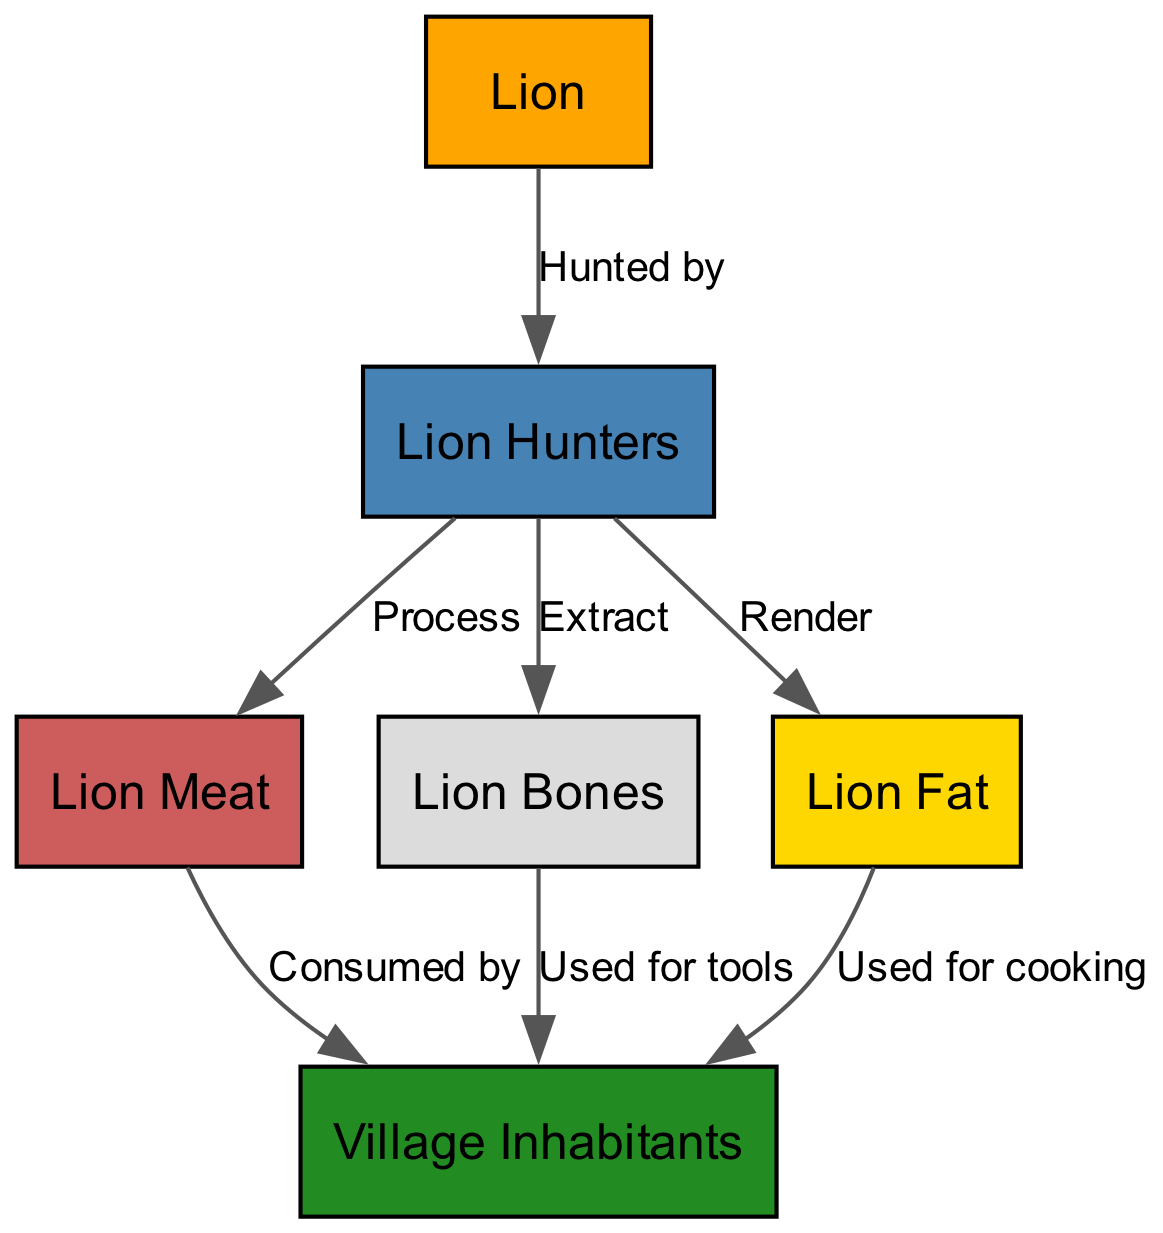What is the primary source for the villagers' nutrition? The villagers receive nutrition primarily from lion meat, which is consumed after the hunters process the lion. Therefore, lion meat serves as the direct source of nutrition for the villagers.
Answer: Lion Meat How many nodes are present in the diagram? The nodes in the diagram represent the main entities involved in the food chain: Lion, Village Inhabitants, Lion Hunters, Lion Meat, Lion Bones, and Lion Fat, totaling six distinct nodes.
Answer: 6 What do hunters extract from the lion? According to the diagram, hunters extract bones from the lion, which are then used by villagers for tools. Thus, hunters' extraction focuses on the lion bones.
Answer: Bones What do villagers use lion fat for? As shown in the diagram, the villagers use lion fat specifically for cooking purposes, indicating its role in meal preparation.
Answer: Cooking Which component of the lion is processed by hunters for consumption? The component of the lion that is specifically processed by hunters for the consumption of villagers is the meat, as highlighted by the 'Process' connection in the diagram.
Answer: Meat What do villagers use bones for? The villagers utilize bones to create tools, a relationship indicated in the diagram where bones are connected to villagers for this particular purpose.
Answer: Tools How many edges are there in the diagram? To determine the number of edges, we count all the directed connections between nodes: Hunted by, Process, Extract, Render, Consumed by, Used for tools, and Used for cooking, resulting in a total of seven edges.
Answer: 7 Who processes the lion after it is hunted? The hunters are responsible for processing the lion after it has been hunted, as indicated by the directed edge from 'hunters' to 'meat.'
Answer: Hunters What do hunters render from the lion? Hunters render fat from the lion, as stated in the diagram, connecting the hunters directly to the fat resource.
Answer: Fat 